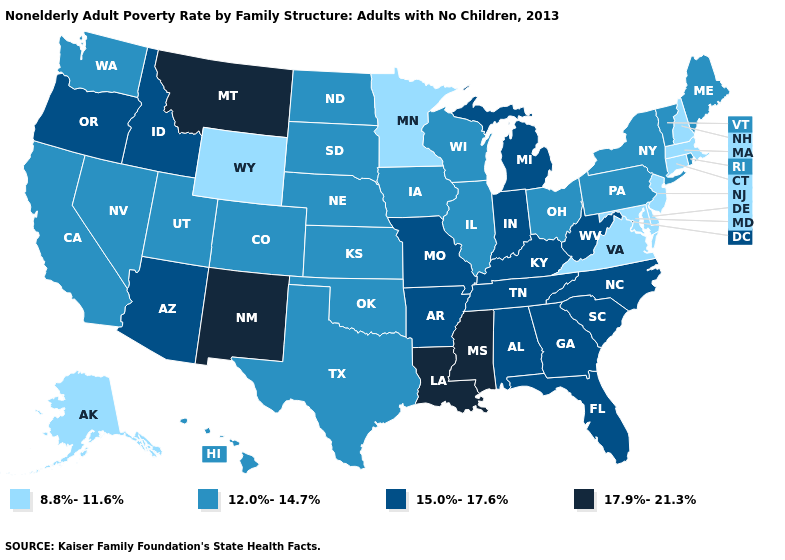Does New Hampshire have the lowest value in the USA?
Quick response, please. Yes. Which states have the highest value in the USA?
Write a very short answer. Louisiana, Mississippi, Montana, New Mexico. Does Louisiana have the highest value in the USA?
Concise answer only. Yes. Among the states that border Arizona , does New Mexico have the lowest value?
Short answer required. No. Which states have the lowest value in the USA?
Give a very brief answer. Alaska, Connecticut, Delaware, Maryland, Massachusetts, Minnesota, New Hampshire, New Jersey, Virginia, Wyoming. How many symbols are there in the legend?
Be succinct. 4. What is the value of Utah?
Quick response, please. 12.0%-14.7%. What is the highest value in states that border Virginia?
Quick response, please. 15.0%-17.6%. What is the value of Minnesota?
Concise answer only. 8.8%-11.6%. Among the states that border Nebraska , which have the highest value?
Quick response, please. Missouri. What is the value of West Virginia?
Concise answer only. 15.0%-17.6%. Which states hav the highest value in the MidWest?
Keep it brief. Indiana, Michigan, Missouri. Does the first symbol in the legend represent the smallest category?
Quick response, please. Yes. What is the highest value in the USA?
Concise answer only. 17.9%-21.3%. 